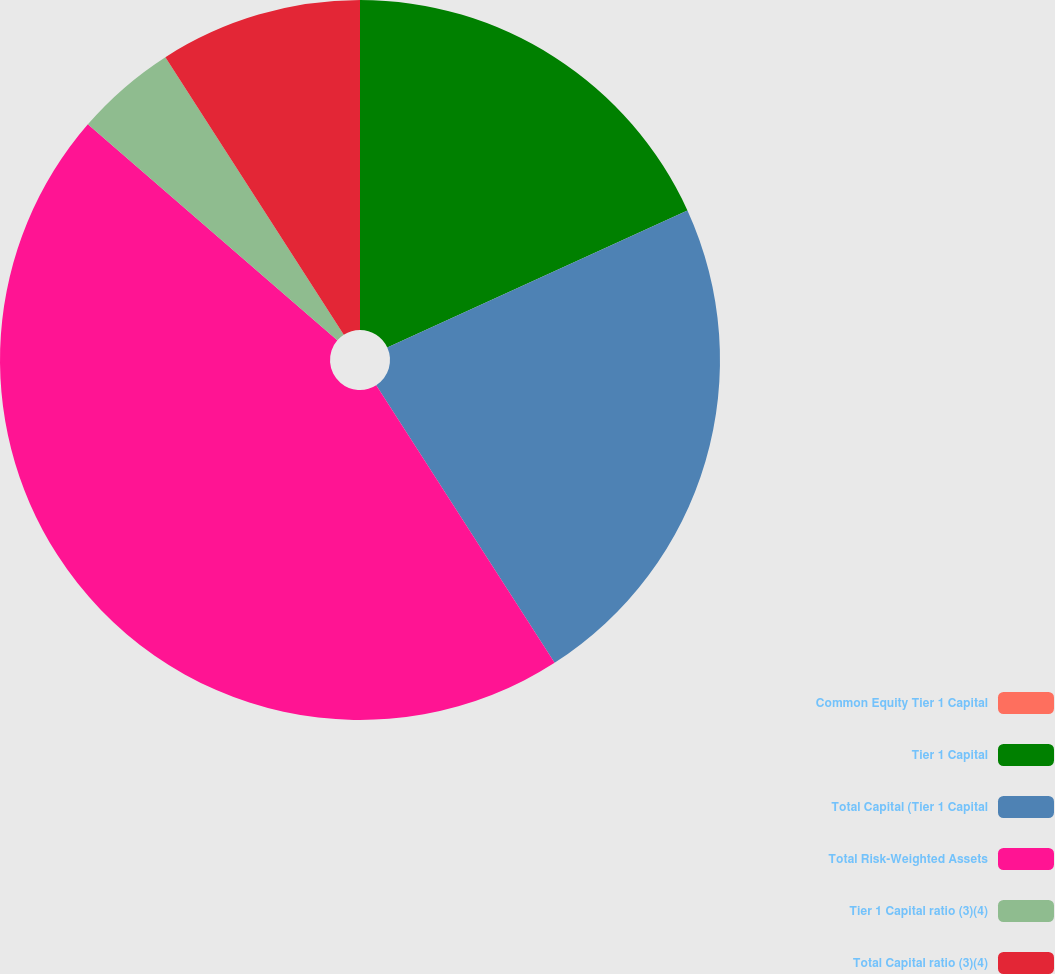<chart> <loc_0><loc_0><loc_500><loc_500><pie_chart><fcel>Common Equity Tier 1 Capital<fcel>Tier 1 Capital<fcel>Total Capital (Tier 1 Capital<fcel>Total Risk-Weighted Assets<fcel>Tier 1 Capital ratio (3)(4)<fcel>Total Capital ratio (3)(4)<nl><fcel>0.0%<fcel>18.18%<fcel>22.73%<fcel>45.45%<fcel>4.55%<fcel>9.09%<nl></chart> 